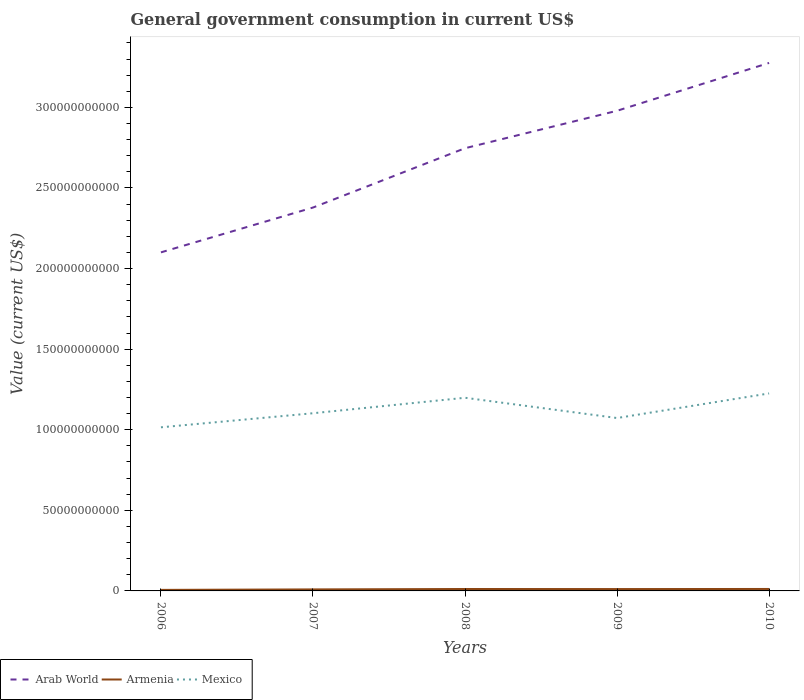How many different coloured lines are there?
Provide a short and direct response. 3. Across all years, what is the maximum government conusmption in Arab World?
Your answer should be very brief. 2.10e+11. What is the total government conusmption in Mexico in the graph?
Give a very brief answer. -5.76e+09. What is the difference between the highest and the second highest government conusmption in Arab World?
Give a very brief answer. 1.18e+11. What is the difference between the highest and the lowest government conusmption in Armenia?
Offer a very short reply. 3. Is the government conusmption in Arab World strictly greater than the government conusmption in Armenia over the years?
Provide a short and direct response. No. Are the values on the major ticks of Y-axis written in scientific E-notation?
Your response must be concise. No. Does the graph contain grids?
Your response must be concise. No. Where does the legend appear in the graph?
Offer a terse response. Bottom left. How many legend labels are there?
Make the answer very short. 3. How are the legend labels stacked?
Ensure brevity in your answer.  Horizontal. What is the title of the graph?
Keep it short and to the point. General government consumption in current US$. Does "World" appear as one of the legend labels in the graph?
Offer a very short reply. No. What is the label or title of the X-axis?
Ensure brevity in your answer.  Years. What is the label or title of the Y-axis?
Your response must be concise. Value (current US$). What is the Value (current US$) in Arab World in 2006?
Provide a succinct answer. 2.10e+11. What is the Value (current US$) in Armenia in 2006?
Your answer should be very brief. 6.44e+08. What is the Value (current US$) of Mexico in 2006?
Offer a very short reply. 1.02e+11. What is the Value (current US$) of Arab World in 2007?
Your response must be concise. 2.38e+11. What is the Value (current US$) in Armenia in 2007?
Your answer should be compact. 9.37e+08. What is the Value (current US$) in Mexico in 2007?
Make the answer very short. 1.10e+11. What is the Value (current US$) of Arab World in 2008?
Your answer should be very brief. 2.75e+11. What is the Value (current US$) of Armenia in 2008?
Ensure brevity in your answer.  1.19e+09. What is the Value (current US$) of Mexico in 2008?
Provide a succinct answer. 1.20e+11. What is the Value (current US$) of Arab World in 2009?
Keep it short and to the point. 2.98e+11. What is the Value (current US$) in Armenia in 2009?
Your response must be concise. 1.15e+09. What is the Value (current US$) of Mexico in 2009?
Provide a short and direct response. 1.07e+11. What is the Value (current US$) of Arab World in 2010?
Provide a succinct answer. 3.28e+11. What is the Value (current US$) in Armenia in 2010?
Make the answer very short. 1.21e+09. What is the Value (current US$) of Mexico in 2010?
Ensure brevity in your answer.  1.23e+11. Across all years, what is the maximum Value (current US$) in Arab World?
Give a very brief answer. 3.28e+11. Across all years, what is the maximum Value (current US$) of Armenia?
Ensure brevity in your answer.  1.21e+09. Across all years, what is the maximum Value (current US$) of Mexico?
Ensure brevity in your answer.  1.23e+11. Across all years, what is the minimum Value (current US$) of Arab World?
Your answer should be very brief. 2.10e+11. Across all years, what is the minimum Value (current US$) in Armenia?
Provide a succinct answer. 6.44e+08. Across all years, what is the minimum Value (current US$) in Mexico?
Provide a succinct answer. 1.02e+11. What is the total Value (current US$) of Arab World in the graph?
Your response must be concise. 1.35e+12. What is the total Value (current US$) of Armenia in the graph?
Offer a terse response. 5.14e+09. What is the total Value (current US$) of Mexico in the graph?
Your answer should be compact. 5.61e+11. What is the difference between the Value (current US$) in Arab World in 2006 and that in 2007?
Provide a succinct answer. -2.78e+1. What is the difference between the Value (current US$) of Armenia in 2006 and that in 2007?
Keep it short and to the point. -2.92e+08. What is the difference between the Value (current US$) of Mexico in 2006 and that in 2007?
Make the answer very short. -8.73e+09. What is the difference between the Value (current US$) in Arab World in 2006 and that in 2008?
Keep it short and to the point. -6.46e+1. What is the difference between the Value (current US$) in Armenia in 2006 and that in 2008?
Provide a short and direct response. -5.49e+08. What is the difference between the Value (current US$) in Mexico in 2006 and that in 2008?
Offer a very short reply. -1.83e+1. What is the difference between the Value (current US$) of Arab World in 2006 and that in 2009?
Your answer should be very brief. -8.78e+1. What is the difference between the Value (current US$) in Armenia in 2006 and that in 2009?
Your answer should be very brief. -5.09e+08. What is the difference between the Value (current US$) of Mexico in 2006 and that in 2009?
Offer a terse response. -5.76e+09. What is the difference between the Value (current US$) of Arab World in 2006 and that in 2010?
Your response must be concise. -1.18e+11. What is the difference between the Value (current US$) of Armenia in 2006 and that in 2010?
Offer a very short reply. -5.66e+08. What is the difference between the Value (current US$) in Mexico in 2006 and that in 2010?
Your answer should be very brief. -2.10e+1. What is the difference between the Value (current US$) of Arab World in 2007 and that in 2008?
Ensure brevity in your answer.  -3.68e+1. What is the difference between the Value (current US$) of Armenia in 2007 and that in 2008?
Your response must be concise. -2.56e+08. What is the difference between the Value (current US$) in Mexico in 2007 and that in 2008?
Keep it short and to the point. -9.60e+09. What is the difference between the Value (current US$) of Arab World in 2007 and that in 2009?
Provide a succinct answer. -6.00e+1. What is the difference between the Value (current US$) in Armenia in 2007 and that in 2009?
Offer a very short reply. -2.17e+08. What is the difference between the Value (current US$) of Mexico in 2007 and that in 2009?
Your answer should be compact. 2.97e+09. What is the difference between the Value (current US$) in Arab World in 2007 and that in 2010?
Your answer should be compact. -8.97e+1. What is the difference between the Value (current US$) of Armenia in 2007 and that in 2010?
Your response must be concise. -2.74e+08. What is the difference between the Value (current US$) in Mexico in 2007 and that in 2010?
Your answer should be very brief. -1.23e+1. What is the difference between the Value (current US$) in Arab World in 2008 and that in 2009?
Ensure brevity in your answer.  -2.32e+1. What is the difference between the Value (current US$) in Armenia in 2008 and that in 2009?
Ensure brevity in your answer.  3.96e+07. What is the difference between the Value (current US$) in Mexico in 2008 and that in 2009?
Your answer should be compact. 1.26e+1. What is the difference between the Value (current US$) in Arab World in 2008 and that in 2010?
Provide a succinct answer. -5.29e+1. What is the difference between the Value (current US$) in Armenia in 2008 and that in 2010?
Ensure brevity in your answer.  -1.75e+07. What is the difference between the Value (current US$) in Mexico in 2008 and that in 2010?
Keep it short and to the point. -2.70e+09. What is the difference between the Value (current US$) of Arab World in 2009 and that in 2010?
Your answer should be compact. -2.97e+1. What is the difference between the Value (current US$) of Armenia in 2009 and that in 2010?
Your response must be concise. -5.71e+07. What is the difference between the Value (current US$) in Mexico in 2009 and that in 2010?
Offer a terse response. -1.53e+1. What is the difference between the Value (current US$) in Arab World in 2006 and the Value (current US$) in Armenia in 2007?
Give a very brief answer. 2.09e+11. What is the difference between the Value (current US$) in Arab World in 2006 and the Value (current US$) in Mexico in 2007?
Your answer should be compact. 9.98e+1. What is the difference between the Value (current US$) in Armenia in 2006 and the Value (current US$) in Mexico in 2007?
Offer a terse response. -1.10e+11. What is the difference between the Value (current US$) in Arab World in 2006 and the Value (current US$) in Armenia in 2008?
Provide a succinct answer. 2.09e+11. What is the difference between the Value (current US$) in Arab World in 2006 and the Value (current US$) in Mexico in 2008?
Provide a succinct answer. 9.02e+1. What is the difference between the Value (current US$) of Armenia in 2006 and the Value (current US$) of Mexico in 2008?
Your response must be concise. -1.19e+11. What is the difference between the Value (current US$) in Arab World in 2006 and the Value (current US$) in Armenia in 2009?
Offer a very short reply. 2.09e+11. What is the difference between the Value (current US$) of Arab World in 2006 and the Value (current US$) of Mexico in 2009?
Make the answer very short. 1.03e+11. What is the difference between the Value (current US$) of Armenia in 2006 and the Value (current US$) of Mexico in 2009?
Your answer should be very brief. -1.07e+11. What is the difference between the Value (current US$) in Arab World in 2006 and the Value (current US$) in Armenia in 2010?
Ensure brevity in your answer.  2.09e+11. What is the difference between the Value (current US$) of Arab World in 2006 and the Value (current US$) of Mexico in 2010?
Offer a very short reply. 8.75e+1. What is the difference between the Value (current US$) in Armenia in 2006 and the Value (current US$) in Mexico in 2010?
Your response must be concise. -1.22e+11. What is the difference between the Value (current US$) of Arab World in 2007 and the Value (current US$) of Armenia in 2008?
Offer a very short reply. 2.37e+11. What is the difference between the Value (current US$) of Arab World in 2007 and the Value (current US$) of Mexico in 2008?
Give a very brief answer. 1.18e+11. What is the difference between the Value (current US$) of Armenia in 2007 and the Value (current US$) of Mexico in 2008?
Your response must be concise. -1.19e+11. What is the difference between the Value (current US$) of Arab World in 2007 and the Value (current US$) of Armenia in 2009?
Offer a terse response. 2.37e+11. What is the difference between the Value (current US$) in Arab World in 2007 and the Value (current US$) in Mexico in 2009?
Provide a succinct answer. 1.31e+11. What is the difference between the Value (current US$) in Armenia in 2007 and the Value (current US$) in Mexico in 2009?
Provide a succinct answer. -1.06e+11. What is the difference between the Value (current US$) in Arab World in 2007 and the Value (current US$) in Armenia in 2010?
Provide a short and direct response. 2.37e+11. What is the difference between the Value (current US$) of Arab World in 2007 and the Value (current US$) of Mexico in 2010?
Make the answer very short. 1.15e+11. What is the difference between the Value (current US$) of Armenia in 2007 and the Value (current US$) of Mexico in 2010?
Give a very brief answer. -1.22e+11. What is the difference between the Value (current US$) in Arab World in 2008 and the Value (current US$) in Armenia in 2009?
Offer a very short reply. 2.74e+11. What is the difference between the Value (current US$) of Arab World in 2008 and the Value (current US$) of Mexico in 2009?
Give a very brief answer. 1.67e+11. What is the difference between the Value (current US$) of Armenia in 2008 and the Value (current US$) of Mexico in 2009?
Ensure brevity in your answer.  -1.06e+11. What is the difference between the Value (current US$) of Arab World in 2008 and the Value (current US$) of Armenia in 2010?
Provide a succinct answer. 2.73e+11. What is the difference between the Value (current US$) of Arab World in 2008 and the Value (current US$) of Mexico in 2010?
Make the answer very short. 1.52e+11. What is the difference between the Value (current US$) in Armenia in 2008 and the Value (current US$) in Mexico in 2010?
Ensure brevity in your answer.  -1.21e+11. What is the difference between the Value (current US$) of Arab World in 2009 and the Value (current US$) of Armenia in 2010?
Make the answer very short. 2.97e+11. What is the difference between the Value (current US$) of Arab World in 2009 and the Value (current US$) of Mexico in 2010?
Offer a very short reply. 1.75e+11. What is the difference between the Value (current US$) in Armenia in 2009 and the Value (current US$) in Mexico in 2010?
Provide a succinct answer. -1.21e+11. What is the average Value (current US$) of Arab World per year?
Offer a terse response. 2.70e+11. What is the average Value (current US$) of Armenia per year?
Offer a very short reply. 1.03e+09. What is the average Value (current US$) of Mexico per year?
Keep it short and to the point. 1.12e+11. In the year 2006, what is the difference between the Value (current US$) of Arab World and Value (current US$) of Armenia?
Your answer should be compact. 2.09e+11. In the year 2006, what is the difference between the Value (current US$) in Arab World and Value (current US$) in Mexico?
Offer a terse response. 1.09e+11. In the year 2006, what is the difference between the Value (current US$) in Armenia and Value (current US$) in Mexico?
Give a very brief answer. -1.01e+11. In the year 2007, what is the difference between the Value (current US$) in Arab World and Value (current US$) in Armenia?
Provide a short and direct response. 2.37e+11. In the year 2007, what is the difference between the Value (current US$) of Arab World and Value (current US$) of Mexico?
Make the answer very short. 1.28e+11. In the year 2007, what is the difference between the Value (current US$) of Armenia and Value (current US$) of Mexico?
Your answer should be compact. -1.09e+11. In the year 2008, what is the difference between the Value (current US$) of Arab World and Value (current US$) of Armenia?
Make the answer very short. 2.73e+11. In the year 2008, what is the difference between the Value (current US$) in Arab World and Value (current US$) in Mexico?
Offer a terse response. 1.55e+11. In the year 2008, what is the difference between the Value (current US$) of Armenia and Value (current US$) of Mexico?
Your response must be concise. -1.19e+11. In the year 2009, what is the difference between the Value (current US$) of Arab World and Value (current US$) of Armenia?
Keep it short and to the point. 2.97e+11. In the year 2009, what is the difference between the Value (current US$) in Arab World and Value (current US$) in Mexico?
Provide a succinct answer. 1.91e+11. In the year 2009, what is the difference between the Value (current US$) in Armenia and Value (current US$) in Mexico?
Provide a succinct answer. -1.06e+11. In the year 2010, what is the difference between the Value (current US$) of Arab World and Value (current US$) of Armenia?
Provide a short and direct response. 3.26e+11. In the year 2010, what is the difference between the Value (current US$) in Arab World and Value (current US$) in Mexico?
Your response must be concise. 2.05e+11. In the year 2010, what is the difference between the Value (current US$) of Armenia and Value (current US$) of Mexico?
Provide a succinct answer. -1.21e+11. What is the ratio of the Value (current US$) in Arab World in 2006 to that in 2007?
Ensure brevity in your answer.  0.88. What is the ratio of the Value (current US$) in Armenia in 2006 to that in 2007?
Keep it short and to the point. 0.69. What is the ratio of the Value (current US$) in Mexico in 2006 to that in 2007?
Offer a very short reply. 0.92. What is the ratio of the Value (current US$) of Arab World in 2006 to that in 2008?
Make the answer very short. 0.76. What is the ratio of the Value (current US$) of Armenia in 2006 to that in 2008?
Offer a terse response. 0.54. What is the ratio of the Value (current US$) in Mexico in 2006 to that in 2008?
Ensure brevity in your answer.  0.85. What is the ratio of the Value (current US$) in Arab World in 2006 to that in 2009?
Your answer should be very brief. 0.71. What is the ratio of the Value (current US$) of Armenia in 2006 to that in 2009?
Offer a very short reply. 0.56. What is the ratio of the Value (current US$) of Mexico in 2006 to that in 2009?
Make the answer very short. 0.95. What is the ratio of the Value (current US$) of Arab World in 2006 to that in 2010?
Your answer should be very brief. 0.64. What is the ratio of the Value (current US$) in Armenia in 2006 to that in 2010?
Offer a very short reply. 0.53. What is the ratio of the Value (current US$) of Mexico in 2006 to that in 2010?
Make the answer very short. 0.83. What is the ratio of the Value (current US$) of Arab World in 2007 to that in 2008?
Your response must be concise. 0.87. What is the ratio of the Value (current US$) of Armenia in 2007 to that in 2008?
Your response must be concise. 0.79. What is the ratio of the Value (current US$) of Mexico in 2007 to that in 2008?
Provide a short and direct response. 0.92. What is the ratio of the Value (current US$) of Arab World in 2007 to that in 2009?
Provide a short and direct response. 0.8. What is the ratio of the Value (current US$) of Armenia in 2007 to that in 2009?
Your answer should be compact. 0.81. What is the ratio of the Value (current US$) in Mexico in 2007 to that in 2009?
Offer a terse response. 1.03. What is the ratio of the Value (current US$) in Arab World in 2007 to that in 2010?
Provide a short and direct response. 0.73. What is the ratio of the Value (current US$) of Armenia in 2007 to that in 2010?
Provide a short and direct response. 0.77. What is the ratio of the Value (current US$) in Mexico in 2007 to that in 2010?
Provide a succinct answer. 0.9. What is the ratio of the Value (current US$) in Arab World in 2008 to that in 2009?
Make the answer very short. 0.92. What is the ratio of the Value (current US$) of Armenia in 2008 to that in 2009?
Keep it short and to the point. 1.03. What is the ratio of the Value (current US$) in Mexico in 2008 to that in 2009?
Offer a terse response. 1.12. What is the ratio of the Value (current US$) in Arab World in 2008 to that in 2010?
Provide a succinct answer. 0.84. What is the ratio of the Value (current US$) of Armenia in 2008 to that in 2010?
Your response must be concise. 0.99. What is the ratio of the Value (current US$) in Arab World in 2009 to that in 2010?
Keep it short and to the point. 0.91. What is the ratio of the Value (current US$) in Armenia in 2009 to that in 2010?
Offer a very short reply. 0.95. What is the ratio of the Value (current US$) in Mexico in 2009 to that in 2010?
Your answer should be compact. 0.88. What is the difference between the highest and the second highest Value (current US$) in Arab World?
Offer a very short reply. 2.97e+1. What is the difference between the highest and the second highest Value (current US$) of Armenia?
Keep it short and to the point. 1.75e+07. What is the difference between the highest and the second highest Value (current US$) of Mexico?
Ensure brevity in your answer.  2.70e+09. What is the difference between the highest and the lowest Value (current US$) in Arab World?
Provide a short and direct response. 1.18e+11. What is the difference between the highest and the lowest Value (current US$) in Armenia?
Your response must be concise. 5.66e+08. What is the difference between the highest and the lowest Value (current US$) in Mexico?
Ensure brevity in your answer.  2.10e+1. 